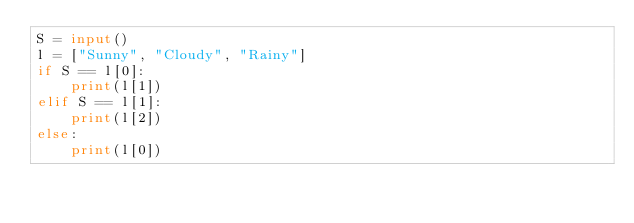<code> <loc_0><loc_0><loc_500><loc_500><_Python_>S = input()
l = ["Sunny", "Cloudy", "Rainy"]
if S == l[0]:
    print(l[1])
elif S == l[1]:
    print(l[2])
else:
    print(l[0])</code> 